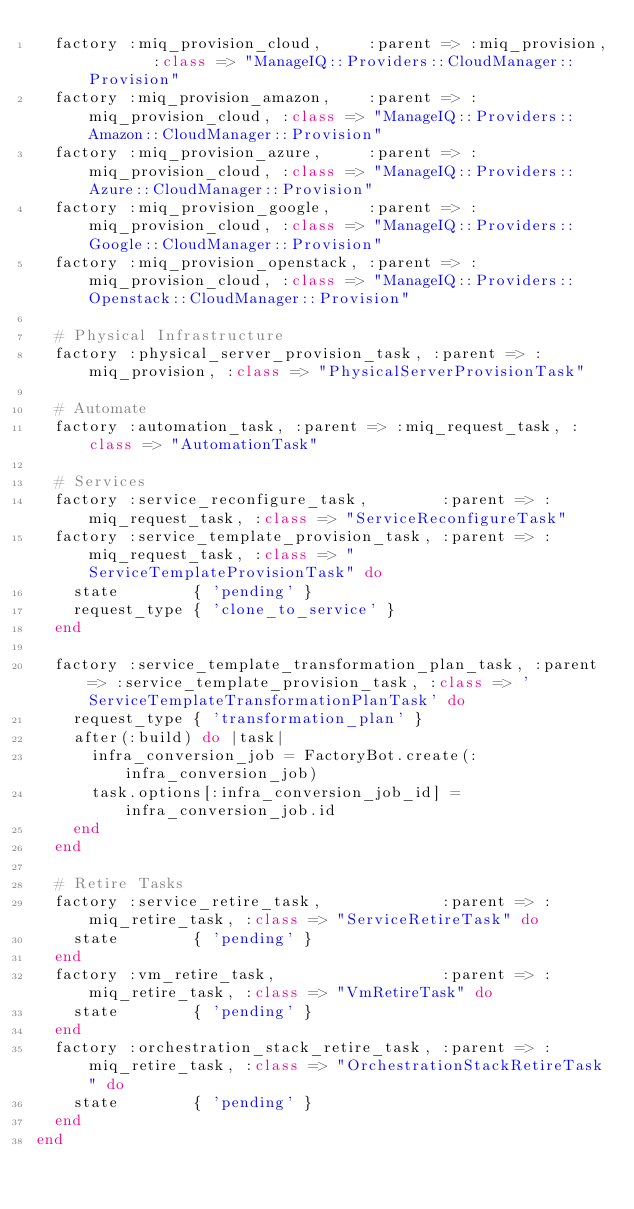Convert code to text. <code><loc_0><loc_0><loc_500><loc_500><_Ruby_>  factory :miq_provision_cloud,     :parent => :miq_provision,       :class => "ManageIQ::Providers::CloudManager::Provision"
  factory :miq_provision_amazon,    :parent => :miq_provision_cloud, :class => "ManageIQ::Providers::Amazon::CloudManager::Provision"
  factory :miq_provision_azure,     :parent => :miq_provision_cloud, :class => "ManageIQ::Providers::Azure::CloudManager::Provision"
  factory :miq_provision_google,    :parent => :miq_provision_cloud, :class => "ManageIQ::Providers::Google::CloudManager::Provision"
  factory :miq_provision_openstack, :parent => :miq_provision_cloud, :class => "ManageIQ::Providers::Openstack::CloudManager::Provision"

  # Physical Infrastructure
  factory :physical_server_provision_task, :parent => :miq_provision, :class => "PhysicalServerProvisionTask"

  # Automate
  factory :automation_task, :parent => :miq_request_task, :class => "AutomationTask"

  # Services
  factory :service_reconfigure_task,        :parent => :miq_request_task, :class => "ServiceReconfigureTask"
  factory :service_template_provision_task, :parent => :miq_request_task, :class => "ServiceTemplateProvisionTask" do
    state        { 'pending' }
    request_type { 'clone_to_service' }
  end

  factory :service_template_transformation_plan_task, :parent => :service_template_provision_task, :class => 'ServiceTemplateTransformationPlanTask' do
    request_type { 'transformation_plan' }
    after(:build) do |task|
      infra_conversion_job = FactoryBot.create(:infra_conversion_job)
      task.options[:infra_conversion_job_id] = infra_conversion_job.id
    end
  end

  # Retire Tasks
  factory :service_retire_task,             :parent => :miq_retire_task, :class => "ServiceRetireTask" do
    state        { 'pending' }
  end
  factory :vm_retire_task,                  :parent => :miq_retire_task, :class => "VmRetireTask" do
    state        { 'pending' }
  end
  factory :orchestration_stack_retire_task, :parent => :miq_retire_task, :class => "OrchestrationStackRetireTask" do
    state        { 'pending' }
  end
end
</code> 